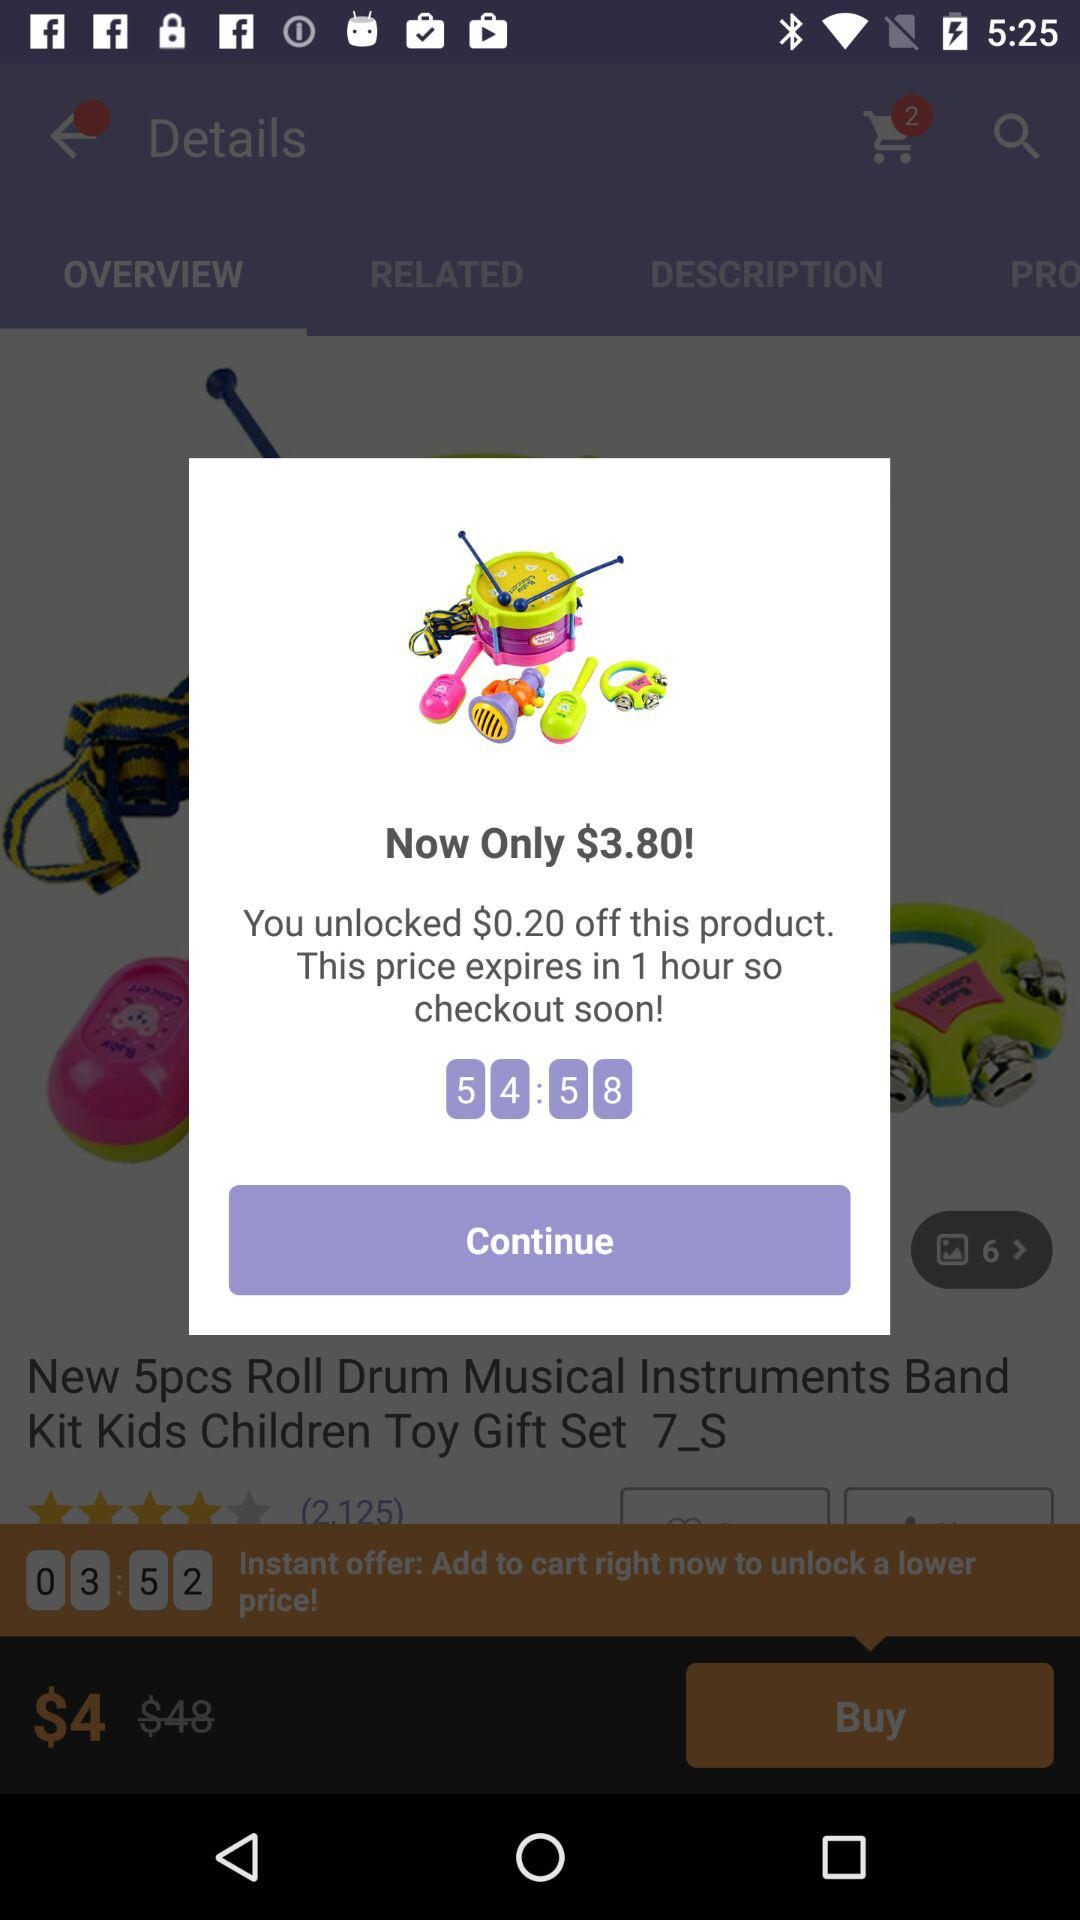What is the time duration of the offer? The time duration is 1 hour. 